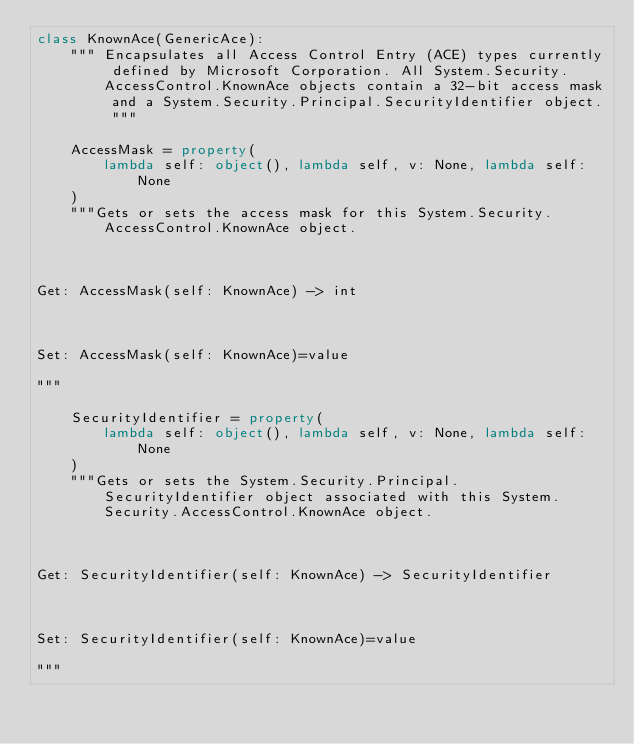<code> <loc_0><loc_0><loc_500><loc_500><_Python_>class KnownAce(GenericAce):
    """ Encapsulates all Access Control Entry (ACE) types currently defined by Microsoft Corporation. All System.Security.AccessControl.KnownAce objects contain a 32-bit access mask and a System.Security.Principal.SecurityIdentifier object. """

    AccessMask = property(
        lambda self: object(), lambda self, v: None, lambda self: None
    )
    """Gets or sets the access mask for this System.Security.AccessControl.KnownAce object.



Get: AccessMask(self: KnownAce) -> int



Set: AccessMask(self: KnownAce)=value

"""

    SecurityIdentifier = property(
        lambda self: object(), lambda self, v: None, lambda self: None
    )
    """Gets or sets the System.Security.Principal.SecurityIdentifier object associated with this System.Security.AccessControl.KnownAce object.



Get: SecurityIdentifier(self: KnownAce) -> SecurityIdentifier



Set: SecurityIdentifier(self: KnownAce)=value

"""
</code> 